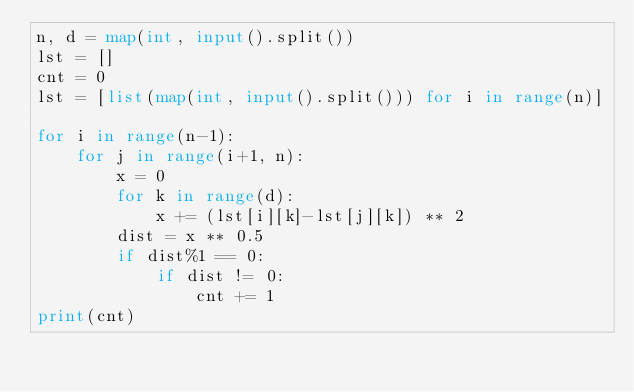Convert code to text. <code><loc_0><loc_0><loc_500><loc_500><_Python_>n, d = map(int, input().split())
lst = []
cnt = 0
lst = [list(map(int, input().split())) for i in range(n)]

for i in range(n-1):
    for j in range(i+1, n):
        x = 0
        for k in range(d):
            x += (lst[i][k]-lst[j][k]) ** 2
        dist = x ** 0.5
        if dist%1 == 0:
            if dist != 0:
                cnt += 1
print(cnt)</code> 